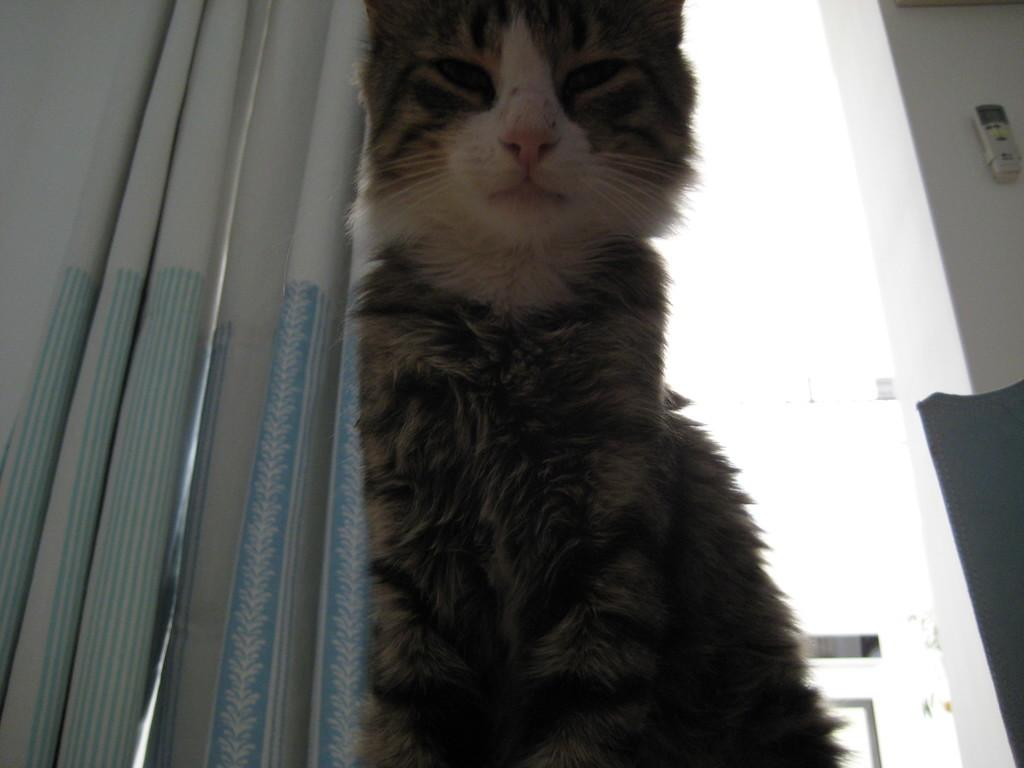What is the main subject in the center of the image? There is a cat in the center of the image. Can you describe any objects or features related to technology in the image? Yes, there is a remote attached to the wall in the image. What type of window treatment is present on the left side of the image? There is a curtain on the left side of the image. How many soldiers are present in the image? There are no soldiers or army-related elements present in the image. What scientific experiment is being conducted in the image? There is no scientific experiment or equipment visible in the image. 